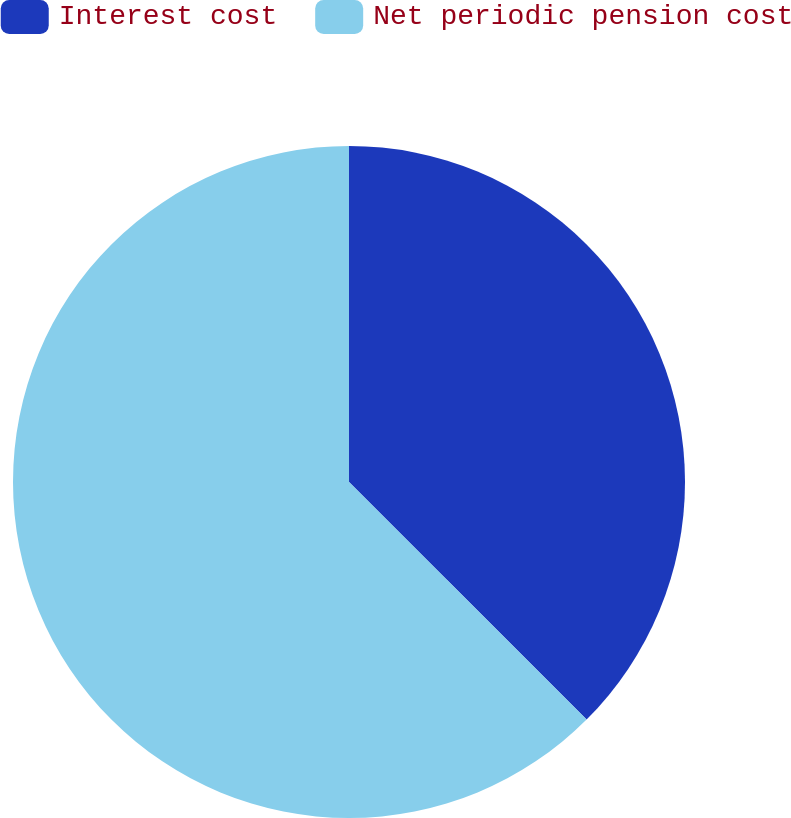Convert chart. <chart><loc_0><loc_0><loc_500><loc_500><pie_chart><fcel>Interest cost<fcel>Net periodic pension cost<nl><fcel>37.5%<fcel>62.5%<nl></chart> 